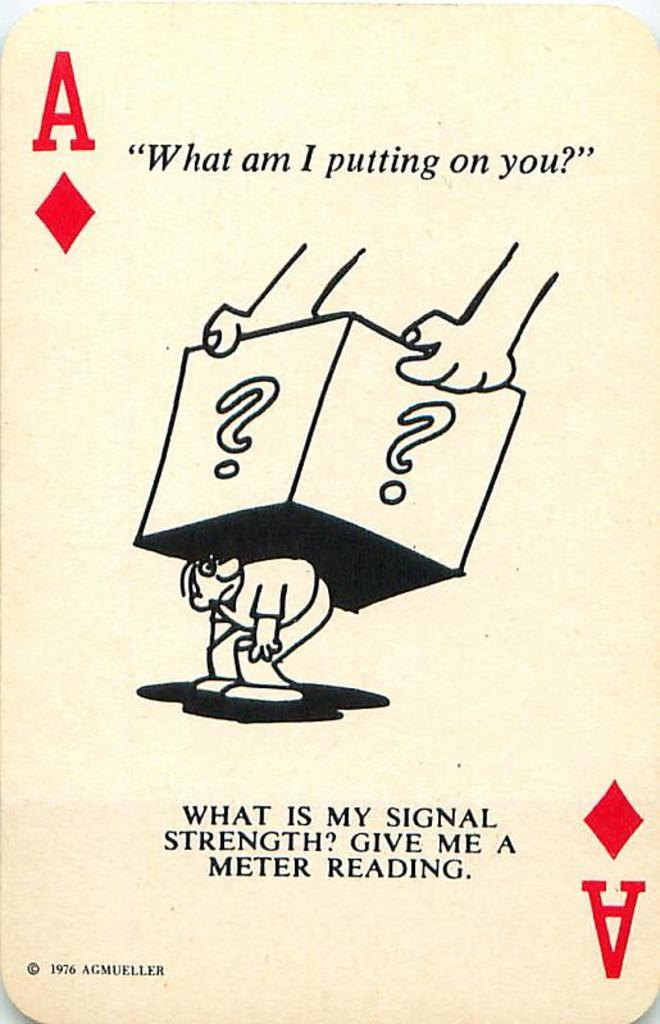<image>
Describe the image concisely. A playing card asking "What am I putting on you?" 